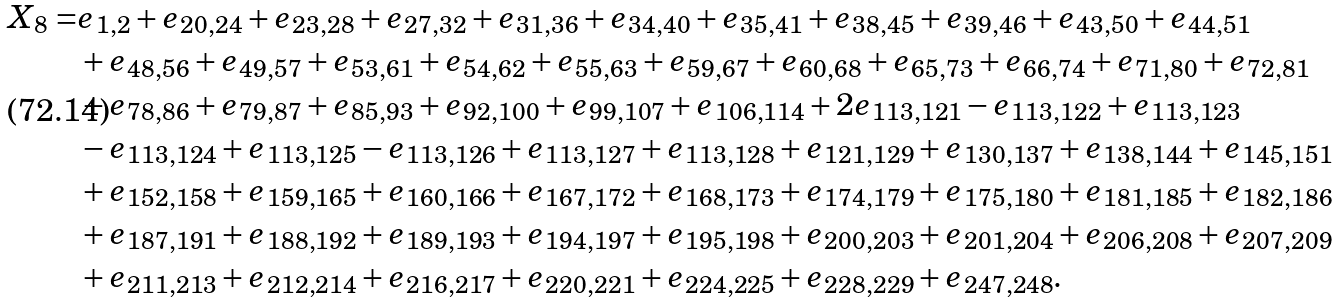<formula> <loc_0><loc_0><loc_500><loc_500>X _ { 8 } = & e _ { 1 , 2 } + e _ { 2 0 , 2 4 } + e _ { 2 3 , 2 8 } + e _ { 2 7 , 3 2 } + e _ { 3 1 , 3 6 } + e _ { 3 4 , 4 0 } + e _ { 3 5 , 4 1 } + e _ { 3 8 , 4 5 } + e _ { 3 9 , 4 6 } + e _ { 4 3 , 5 0 } + e _ { 4 4 , 5 1 } \\ & + e _ { 4 8 , 5 6 } + e _ { 4 9 , 5 7 } + e _ { 5 3 , 6 1 } + e _ { 5 4 , 6 2 } + e _ { 5 5 , 6 3 } + e _ { 5 9 , 6 7 } + e _ { 6 0 , 6 8 } + e _ { 6 5 , 7 3 } + e _ { 6 6 , 7 4 } + e _ { 7 1 , 8 0 } + e _ { 7 2 , 8 1 } \\ & + e _ { 7 8 , 8 6 } + e _ { 7 9 , 8 7 } + e _ { 8 5 , 9 3 } + e _ { 9 2 , 1 0 0 } + e _ { 9 9 , 1 0 7 } + e _ { 1 0 6 , 1 1 4 } + 2 e _ { 1 1 3 , 1 2 1 } - e _ { 1 1 3 , 1 2 2 } + e _ { 1 1 3 , 1 2 3 } \\ & - e _ { 1 1 3 , 1 2 4 } + e _ { 1 1 3 , 1 2 5 } - e _ { 1 1 3 , 1 2 6 } + e _ { 1 1 3 , 1 2 7 } + e _ { 1 1 3 , 1 2 8 } + e _ { 1 2 1 , 1 2 9 } + e _ { 1 3 0 , 1 3 7 } + e _ { 1 3 8 , 1 4 4 } + e _ { 1 4 5 , 1 5 1 } \\ & + e _ { 1 5 2 , 1 5 8 } + e _ { 1 5 9 , 1 6 5 } + e _ { 1 6 0 , 1 6 6 } + e _ { 1 6 7 , 1 7 2 } + e _ { 1 6 8 , 1 7 3 } + e _ { 1 7 4 , 1 7 9 } + e _ { 1 7 5 , 1 8 0 } + e _ { 1 8 1 , 1 8 5 } + e _ { 1 8 2 , 1 8 6 } \\ & + e _ { 1 8 7 , 1 9 1 } + e _ { 1 8 8 , 1 9 2 } + e _ { 1 8 9 , 1 9 3 } + e _ { 1 9 4 , 1 9 7 } + e _ { 1 9 5 , 1 9 8 } + e _ { 2 0 0 , 2 0 3 } + e _ { 2 0 1 , 2 0 4 } + e _ { 2 0 6 , 2 0 8 } + e _ { 2 0 7 , 2 0 9 } \\ & + e _ { 2 1 1 , 2 1 3 } + e _ { 2 1 2 , 2 1 4 } + e _ { 2 1 6 , 2 1 7 } + e _ { 2 2 0 , 2 2 1 } + e _ { 2 2 4 , 2 2 5 } + e _ { 2 2 8 , 2 2 9 } + e _ { 2 4 7 , 2 4 8 } .</formula> 